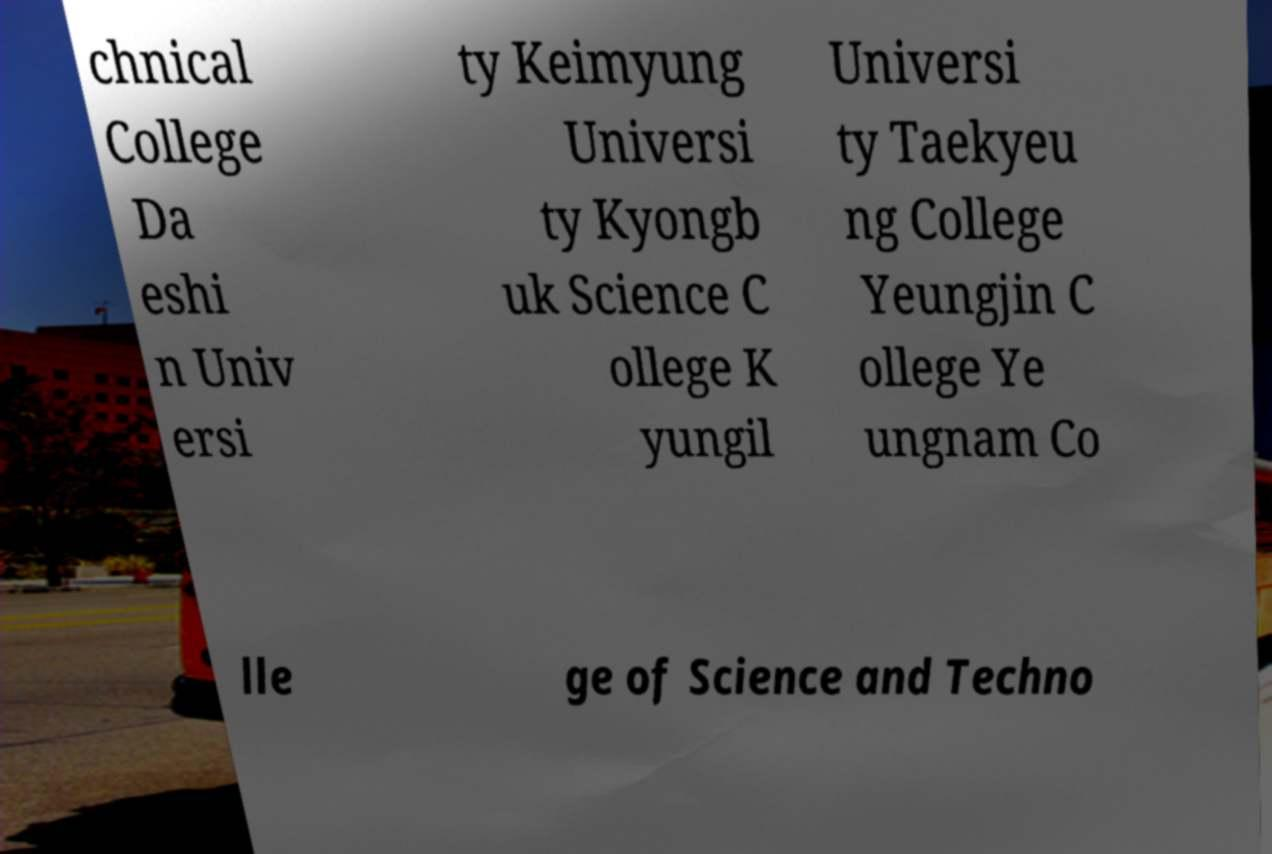Could you assist in decoding the text presented in this image and type it out clearly? chnical College Da eshi n Univ ersi ty Keimyung Universi ty Kyongb uk Science C ollege K yungil Universi ty Taekyeu ng College Yeungjin C ollege Ye ungnam Co lle ge of Science and Techno 